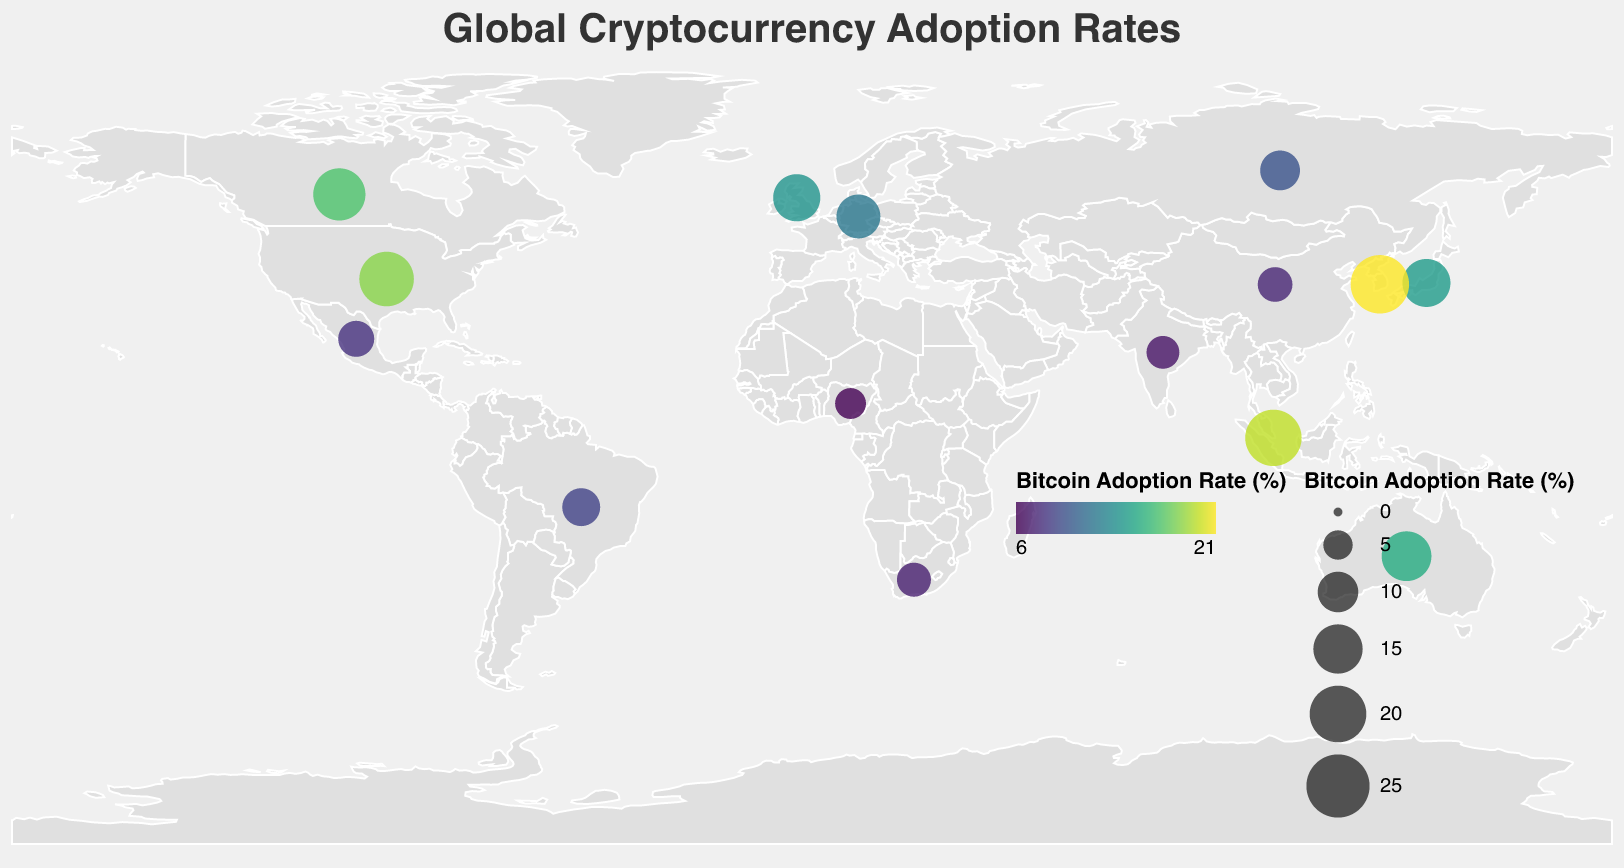Which country has the highest Bitcoin adoption rate? The country with the largest circle represents the highest Bitcoin adoption rate. By observing the figure, South Korea has the largest circle, indicating the highest rate.
Answer: South Korea What is the Bitcoin adoption rate in Japan? Hovering over Japan reveals the tooltip with the Bitcoin adoption rate. By doing this, we see Japan has a 14.2% adoption rate.
Answer: 14.2% How does the Bitcoin adoption rate in the United States compare to that in Canada? Observing the circles representing the United States and Canada, we see the United States has a larger Bitcoin adoption rate (18.5%) compared to Canada (16.9%).
Answer: The United States has a higher adoption rate Which country shows the lowest adoption rate for Litecoin? By looking at the tooltips of each country and checking for the lowest Litecoin value, Nigeria has the lowest rate at 0.4%.
Answer: Nigeria What is the combined adoption rate of Bitcoin and Ethereum in Germany? The tooltip for Germany shows a Bitcoin rate of 11.8% and an Ethereum rate of 8.2%. Adding these together gives 11.8 + 8.2 = 20.
Answer: 20% Observing the plot, which countries exhibit a Bitcoin adoption rate higher than 15%? Countries with larger circles and high values in the tooltips are South Korea (21.3%), Singapore (19.8%), the United States (18.5%), and Canada (16.9%).
Answer: South Korea, Singapore, United States, Canada What is the difference in Dogecoin adoption rate between Australia and Russia? Check the tooltip for both countries. Australia has a Dogecoin rate of 2.9% and Russia has 1.5%. Subtract the smaller value from the larger one: 2.9 - 1.5 = 1.4.
Answer: 1.4% Which cryptocurrency has the second-highest adoption rate in South Korea, and what's the value? The tooltip for South Korea reveals the adoption rates. Ethereum has the second-highest rate after Bitcoin, with a value of 15.6%.
Answer: Ethereum, 15.6% What is the average Bitcoin adoption rate across all displayed countries? Sum up all the Bitcoin rates from the tooltips and divide by the number of countries: (18.5 + 14.2 + 21.3 + 11.8 + 13.7 + 16.9 + 15.3 + 9.6 + 7.2 + 6.4 + 8.7 + 7.8 + 6.9 + 5.6 + 19.8) / 15. The total is 183.8. Average = 183.8 / 15 = 12.3.
Answer: 12.3% 